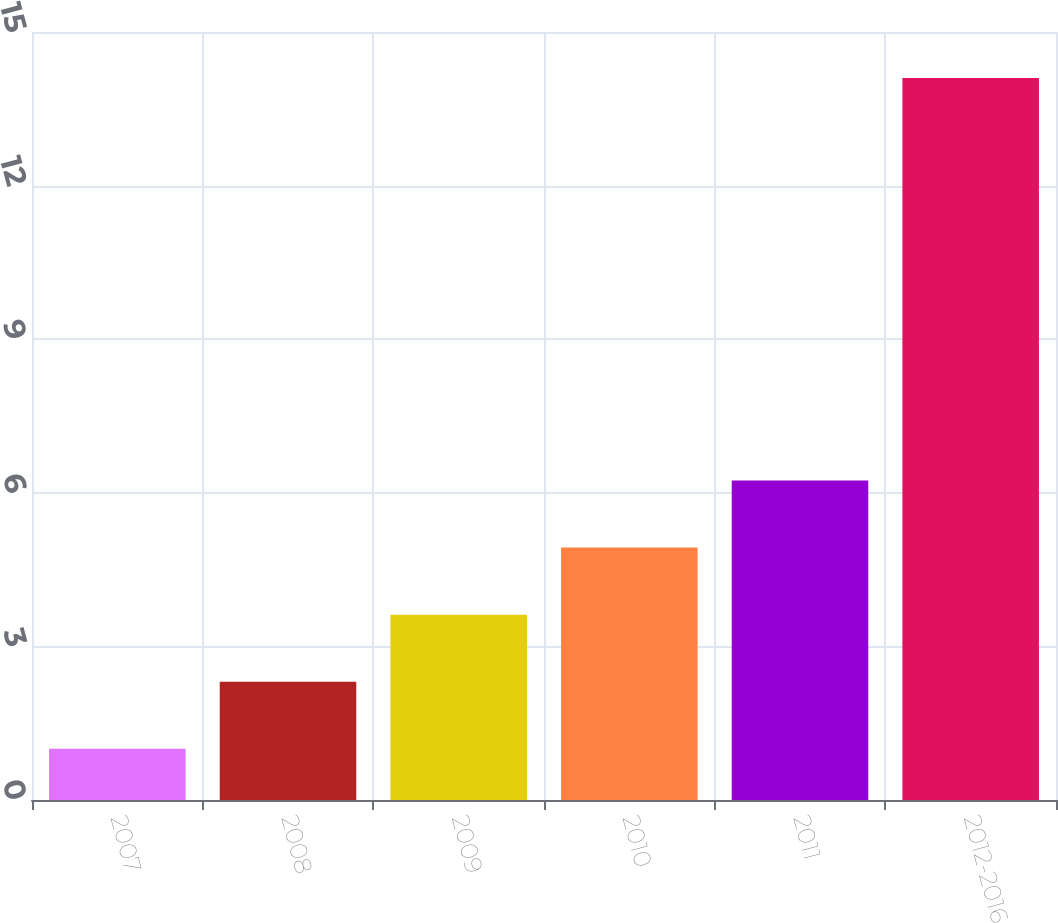Convert chart. <chart><loc_0><loc_0><loc_500><loc_500><bar_chart><fcel>2007<fcel>2008<fcel>2009<fcel>2010<fcel>2011<fcel>2012-2016<nl><fcel>1<fcel>2.31<fcel>3.62<fcel>4.93<fcel>6.24<fcel>14.1<nl></chart> 